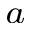Convert formula to latex. <formula><loc_0><loc_0><loc_500><loc_500>^ { a }</formula> 